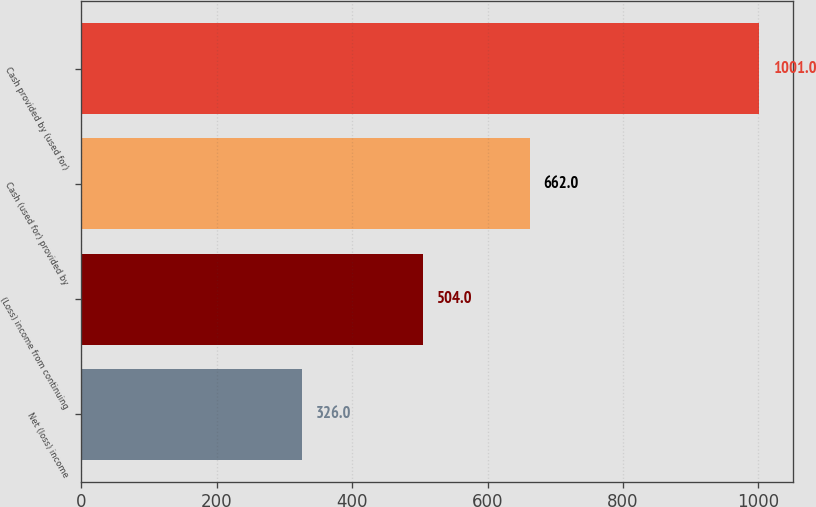Convert chart to OTSL. <chart><loc_0><loc_0><loc_500><loc_500><bar_chart><fcel>Net (loss) income<fcel>(Loss) income from continuing<fcel>Cash (used for) provided by<fcel>Cash provided by (used for)<nl><fcel>326<fcel>504<fcel>662<fcel>1001<nl></chart> 